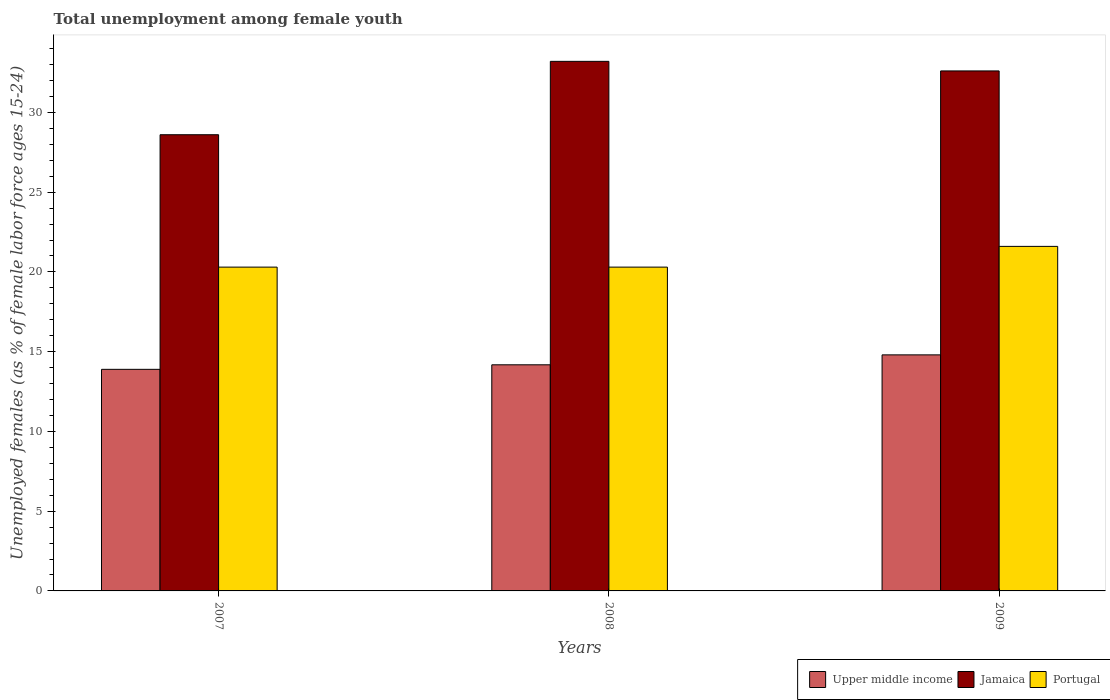Are the number of bars per tick equal to the number of legend labels?
Offer a very short reply. Yes. What is the label of the 3rd group of bars from the left?
Provide a short and direct response. 2009. What is the percentage of unemployed females in in Upper middle income in 2007?
Your answer should be very brief. 13.89. Across all years, what is the maximum percentage of unemployed females in in Portugal?
Offer a very short reply. 21.6. Across all years, what is the minimum percentage of unemployed females in in Portugal?
Keep it short and to the point. 20.3. In which year was the percentage of unemployed females in in Jamaica maximum?
Provide a succinct answer. 2008. What is the total percentage of unemployed females in in Jamaica in the graph?
Offer a very short reply. 94.4. What is the difference between the percentage of unemployed females in in Upper middle income in 2008 and that in 2009?
Ensure brevity in your answer.  -0.62. What is the difference between the percentage of unemployed females in in Portugal in 2007 and the percentage of unemployed females in in Upper middle income in 2009?
Provide a succinct answer. 5.5. What is the average percentage of unemployed females in in Jamaica per year?
Offer a terse response. 31.47. In the year 2007, what is the difference between the percentage of unemployed females in in Jamaica and percentage of unemployed females in in Upper middle income?
Your response must be concise. 14.71. In how many years, is the percentage of unemployed females in in Jamaica greater than 17 %?
Ensure brevity in your answer.  3. What is the ratio of the percentage of unemployed females in in Jamaica in 2008 to that in 2009?
Provide a short and direct response. 1.02. Is the difference between the percentage of unemployed females in in Jamaica in 2007 and 2008 greater than the difference between the percentage of unemployed females in in Upper middle income in 2007 and 2008?
Ensure brevity in your answer.  No. What is the difference between the highest and the second highest percentage of unemployed females in in Jamaica?
Ensure brevity in your answer.  0.6. What is the difference between the highest and the lowest percentage of unemployed females in in Portugal?
Provide a succinct answer. 1.3. What does the 3rd bar from the right in 2009 represents?
Provide a short and direct response. Upper middle income. How many bars are there?
Ensure brevity in your answer.  9. Are all the bars in the graph horizontal?
Offer a terse response. No. What is the difference between two consecutive major ticks on the Y-axis?
Keep it short and to the point. 5. Are the values on the major ticks of Y-axis written in scientific E-notation?
Make the answer very short. No. Does the graph contain grids?
Offer a very short reply. No. What is the title of the graph?
Give a very brief answer. Total unemployment among female youth. What is the label or title of the Y-axis?
Make the answer very short. Unemployed females (as % of female labor force ages 15-24). What is the Unemployed females (as % of female labor force ages 15-24) in Upper middle income in 2007?
Offer a very short reply. 13.89. What is the Unemployed females (as % of female labor force ages 15-24) of Jamaica in 2007?
Give a very brief answer. 28.6. What is the Unemployed females (as % of female labor force ages 15-24) in Portugal in 2007?
Ensure brevity in your answer.  20.3. What is the Unemployed females (as % of female labor force ages 15-24) of Upper middle income in 2008?
Your answer should be very brief. 14.18. What is the Unemployed females (as % of female labor force ages 15-24) in Jamaica in 2008?
Give a very brief answer. 33.2. What is the Unemployed females (as % of female labor force ages 15-24) in Portugal in 2008?
Your answer should be very brief. 20.3. What is the Unemployed females (as % of female labor force ages 15-24) of Upper middle income in 2009?
Provide a succinct answer. 14.8. What is the Unemployed females (as % of female labor force ages 15-24) in Jamaica in 2009?
Your response must be concise. 32.6. What is the Unemployed females (as % of female labor force ages 15-24) of Portugal in 2009?
Your answer should be compact. 21.6. Across all years, what is the maximum Unemployed females (as % of female labor force ages 15-24) of Upper middle income?
Provide a short and direct response. 14.8. Across all years, what is the maximum Unemployed females (as % of female labor force ages 15-24) of Jamaica?
Give a very brief answer. 33.2. Across all years, what is the maximum Unemployed females (as % of female labor force ages 15-24) in Portugal?
Your answer should be compact. 21.6. Across all years, what is the minimum Unemployed females (as % of female labor force ages 15-24) of Upper middle income?
Your answer should be compact. 13.89. Across all years, what is the minimum Unemployed females (as % of female labor force ages 15-24) of Jamaica?
Your answer should be very brief. 28.6. Across all years, what is the minimum Unemployed females (as % of female labor force ages 15-24) of Portugal?
Your response must be concise. 20.3. What is the total Unemployed females (as % of female labor force ages 15-24) of Upper middle income in the graph?
Provide a succinct answer. 42.87. What is the total Unemployed females (as % of female labor force ages 15-24) of Jamaica in the graph?
Make the answer very short. 94.4. What is the total Unemployed females (as % of female labor force ages 15-24) in Portugal in the graph?
Your answer should be compact. 62.2. What is the difference between the Unemployed females (as % of female labor force ages 15-24) in Upper middle income in 2007 and that in 2008?
Provide a succinct answer. -0.28. What is the difference between the Unemployed females (as % of female labor force ages 15-24) in Portugal in 2007 and that in 2008?
Your answer should be compact. 0. What is the difference between the Unemployed females (as % of female labor force ages 15-24) in Upper middle income in 2007 and that in 2009?
Offer a terse response. -0.91. What is the difference between the Unemployed females (as % of female labor force ages 15-24) of Upper middle income in 2008 and that in 2009?
Keep it short and to the point. -0.62. What is the difference between the Unemployed females (as % of female labor force ages 15-24) of Portugal in 2008 and that in 2009?
Your answer should be very brief. -1.3. What is the difference between the Unemployed females (as % of female labor force ages 15-24) of Upper middle income in 2007 and the Unemployed females (as % of female labor force ages 15-24) of Jamaica in 2008?
Provide a short and direct response. -19.31. What is the difference between the Unemployed females (as % of female labor force ages 15-24) of Upper middle income in 2007 and the Unemployed females (as % of female labor force ages 15-24) of Portugal in 2008?
Offer a very short reply. -6.41. What is the difference between the Unemployed females (as % of female labor force ages 15-24) of Jamaica in 2007 and the Unemployed females (as % of female labor force ages 15-24) of Portugal in 2008?
Provide a short and direct response. 8.3. What is the difference between the Unemployed females (as % of female labor force ages 15-24) in Upper middle income in 2007 and the Unemployed females (as % of female labor force ages 15-24) in Jamaica in 2009?
Provide a short and direct response. -18.71. What is the difference between the Unemployed females (as % of female labor force ages 15-24) of Upper middle income in 2007 and the Unemployed females (as % of female labor force ages 15-24) of Portugal in 2009?
Your answer should be compact. -7.71. What is the difference between the Unemployed females (as % of female labor force ages 15-24) in Upper middle income in 2008 and the Unemployed females (as % of female labor force ages 15-24) in Jamaica in 2009?
Your answer should be compact. -18.42. What is the difference between the Unemployed females (as % of female labor force ages 15-24) of Upper middle income in 2008 and the Unemployed females (as % of female labor force ages 15-24) of Portugal in 2009?
Offer a very short reply. -7.42. What is the difference between the Unemployed females (as % of female labor force ages 15-24) in Jamaica in 2008 and the Unemployed females (as % of female labor force ages 15-24) in Portugal in 2009?
Your answer should be compact. 11.6. What is the average Unemployed females (as % of female labor force ages 15-24) in Upper middle income per year?
Offer a terse response. 14.29. What is the average Unemployed females (as % of female labor force ages 15-24) in Jamaica per year?
Ensure brevity in your answer.  31.47. What is the average Unemployed females (as % of female labor force ages 15-24) of Portugal per year?
Provide a short and direct response. 20.73. In the year 2007, what is the difference between the Unemployed females (as % of female labor force ages 15-24) in Upper middle income and Unemployed females (as % of female labor force ages 15-24) in Jamaica?
Provide a succinct answer. -14.71. In the year 2007, what is the difference between the Unemployed females (as % of female labor force ages 15-24) of Upper middle income and Unemployed females (as % of female labor force ages 15-24) of Portugal?
Ensure brevity in your answer.  -6.41. In the year 2008, what is the difference between the Unemployed females (as % of female labor force ages 15-24) in Upper middle income and Unemployed females (as % of female labor force ages 15-24) in Jamaica?
Give a very brief answer. -19.02. In the year 2008, what is the difference between the Unemployed females (as % of female labor force ages 15-24) of Upper middle income and Unemployed females (as % of female labor force ages 15-24) of Portugal?
Offer a very short reply. -6.12. In the year 2008, what is the difference between the Unemployed females (as % of female labor force ages 15-24) in Jamaica and Unemployed females (as % of female labor force ages 15-24) in Portugal?
Your answer should be very brief. 12.9. In the year 2009, what is the difference between the Unemployed females (as % of female labor force ages 15-24) in Upper middle income and Unemployed females (as % of female labor force ages 15-24) in Jamaica?
Offer a terse response. -17.8. In the year 2009, what is the difference between the Unemployed females (as % of female labor force ages 15-24) in Upper middle income and Unemployed females (as % of female labor force ages 15-24) in Portugal?
Your response must be concise. -6.8. What is the ratio of the Unemployed females (as % of female labor force ages 15-24) in Jamaica in 2007 to that in 2008?
Your response must be concise. 0.86. What is the ratio of the Unemployed females (as % of female labor force ages 15-24) of Portugal in 2007 to that in 2008?
Offer a terse response. 1. What is the ratio of the Unemployed females (as % of female labor force ages 15-24) of Upper middle income in 2007 to that in 2009?
Give a very brief answer. 0.94. What is the ratio of the Unemployed females (as % of female labor force ages 15-24) of Jamaica in 2007 to that in 2009?
Provide a short and direct response. 0.88. What is the ratio of the Unemployed females (as % of female labor force ages 15-24) in Portugal in 2007 to that in 2009?
Give a very brief answer. 0.94. What is the ratio of the Unemployed females (as % of female labor force ages 15-24) in Upper middle income in 2008 to that in 2009?
Give a very brief answer. 0.96. What is the ratio of the Unemployed females (as % of female labor force ages 15-24) of Jamaica in 2008 to that in 2009?
Your response must be concise. 1.02. What is the ratio of the Unemployed females (as % of female labor force ages 15-24) in Portugal in 2008 to that in 2009?
Offer a terse response. 0.94. What is the difference between the highest and the second highest Unemployed females (as % of female labor force ages 15-24) in Upper middle income?
Make the answer very short. 0.62. What is the difference between the highest and the lowest Unemployed females (as % of female labor force ages 15-24) of Upper middle income?
Keep it short and to the point. 0.91. What is the difference between the highest and the lowest Unemployed females (as % of female labor force ages 15-24) in Jamaica?
Offer a terse response. 4.6. What is the difference between the highest and the lowest Unemployed females (as % of female labor force ages 15-24) of Portugal?
Offer a terse response. 1.3. 